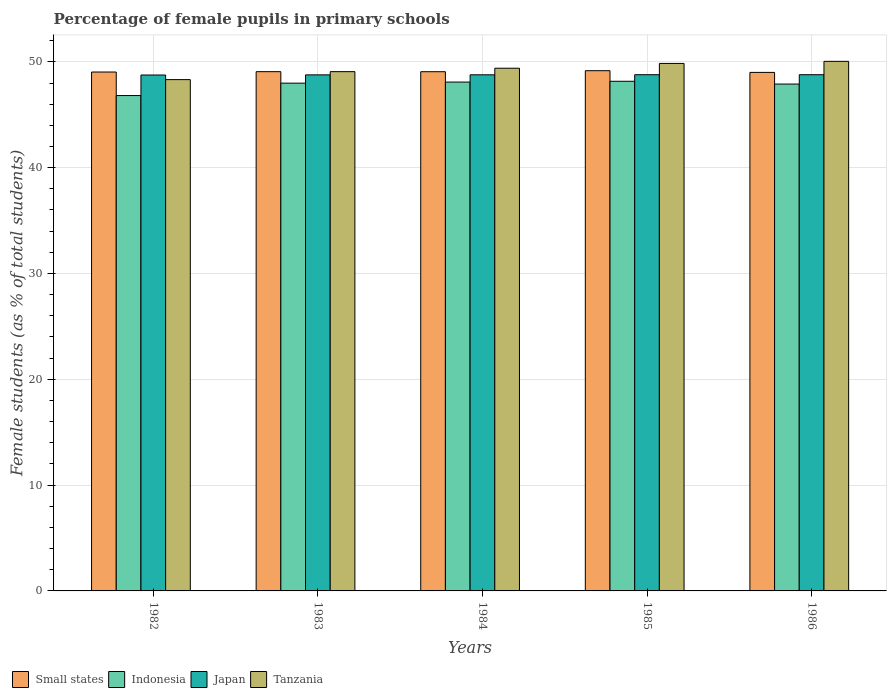How many different coloured bars are there?
Offer a very short reply. 4. How many groups of bars are there?
Offer a very short reply. 5. Are the number of bars per tick equal to the number of legend labels?
Your response must be concise. Yes. What is the percentage of female pupils in primary schools in Indonesia in 1985?
Your response must be concise. 48.16. Across all years, what is the maximum percentage of female pupils in primary schools in Small states?
Give a very brief answer. 49.16. Across all years, what is the minimum percentage of female pupils in primary schools in Japan?
Keep it short and to the point. 48.76. In which year was the percentage of female pupils in primary schools in Tanzania maximum?
Keep it short and to the point. 1986. In which year was the percentage of female pupils in primary schools in Small states minimum?
Give a very brief answer. 1986. What is the total percentage of female pupils in primary schools in Tanzania in the graph?
Keep it short and to the point. 246.69. What is the difference between the percentage of female pupils in primary schools in Small states in 1985 and that in 1986?
Give a very brief answer. 0.16. What is the difference between the percentage of female pupils in primary schools in Japan in 1983 and the percentage of female pupils in primary schools in Tanzania in 1985?
Offer a terse response. -1.08. What is the average percentage of female pupils in primary schools in Japan per year?
Give a very brief answer. 48.77. In the year 1983, what is the difference between the percentage of female pupils in primary schools in Indonesia and percentage of female pupils in primary schools in Small states?
Offer a terse response. -1.09. In how many years, is the percentage of female pupils in primary schools in Japan greater than 38 %?
Your answer should be very brief. 5. What is the ratio of the percentage of female pupils in primary schools in Tanzania in 1985 to that in 1986?
Offer a very short reply. 1. What is the difference between the highest and the second highest percentage of female pupils in primary schools in Tanzania?
Provide a short and direct response. 0.2. What is the difference between the highest and the lowest percentage of female pupils in primary schools in Small states?
Your answer should be compact. 0.16. What does the 4th bar from the left in 1984 represents?
Provide a short and direct response. Tanzania. What does the 4th bar from the right in 1984 represents?
Offer a terse response. Small states. Are all the bars in the graph horizontal?
Provide a succinct answer. No. Are the values on the major ticks of Y-axis written in scientific E-notation?
Your response must be concise. No. Does the graph contain grids?
Your response must be concise. Yes. What is the title of the graph?
Give a very brief answer. Percentage of female pupils in primary schools. Does "Belgium" appear as one of the legend labels in the graph?
Your answer should be very brief. No. What is the label or title of the X-axis?
Provide a succinct answer. Years. What is the label or title of the Y-axis?
Your answer should be compact. Female students (as % of total students). What is the Female students (as % of total students) of Small states in 1982?
Keep it short and to the point. 49.04. What is the Female students (as % of total students) of Indonesia in 1982?
Offer a terse response. 46.81. What is the Female students (as % of total students) in Japan in 1982?
Give a very brief answer. 48.76. What is the Female students (as % of total students) of Tanzania in 1982?
Offer a terse response. 48.32. What is the Female students (as % of total students) in Small states in 1983?
Provide a short and direct response. 49.07. What is the Female students (as % of total students) of Indonesia in 1983?
Keep it short and to the point. 47.99. What is the Female students (as % of total students) in Japan in 1983?
Your response must be concise. 48.77. What is the Female students (as % of total students) of Tanzania in 1983?
Your answer should be compact. 49.07. What is the Female students (as % of total students) of Small states in 1984?
Keep it short and to the point. 49.07. What is the Female students (as % of total students) of Indonesia in 1984?
Provide a succinct answer. 48.09. What is the Female students (as % of total students) of Japan in 1984?
Your answer should be very brief. 48.77. What is the Female students (as % of total students) of Tanzania in 1984?
Make the answer very short. 49.4. What is the Female students (as % of total students) of Small states in 1985?
Provide a short and direct response. 49.16. What is the Female students (as % of total students) of Indonesia in 1985?
Give a very brief answer. 48.16. What is the Female students (as % of total students) in Japan in 1985?
Your answer should be compact. 48.78. What is the Female students (as % of total students) of Tanzania in 1985?
Make the answer very short. 49.85. What is the Female students (as % of total students) in Small states in 1986?
Your response must be concise. 49. What is the Female students (as % of total students) in Indonesia in 1986?
Your answer should be very brief. 47.9. What is the Female students (as % of total students) of Japan in 1986?
Give a very brief answer. 48.79. What is the Female students (as % of total students) in Tanzania in 1986?
Ensure brevity in your answer.  50.05. Across all years, what is the maximum Female students (as % of total students) in Small states?
Offer a terse response. 49.16. Across all years, what is the maximum Female students (as % of total students) of Indonesia?
Offer a terse response. 48.16. Across all years, what is the maximum Female students (as % of total students) of Japan?
Provide a short and direct response. 48.79. Across all years, what is the maximum Female students (as % of total students) in Tanzania?
Provide a succinct answer. 50.05. Across all years, what is the minimum Female students (as % of total students) in Small states?
Provide a short and direct response. 49. Across all years, what is the minimum Female students (as % of total students) of Indonesia?
Your answer should be compact. 46.81. Across all years, what is the minimum Female students (as % of total students) in Japan?
Provide a succinct answer. 48.76. Across all years, what is the minimum Female students (as % of total students) of Tanzania?
Provide a succinct answer. 48.32. What is the total Female students (as % of total students) of Small states in the graph?
Provide a short and direct response. 245.35. What is the total Female students (as % of total students) of Indonesia in the graph?
Your answer should be very brief. 238.95. What is the total Female students (as % of total students) of Japan in the graph?
Provide a short and direct response. 243.87. What is the total Female students (as % of total students) of Tanzania in the graph?
Make the answer very short. 246.69. What is the difference between the Female students (as % of total students) in Small states in 1982 and that in 1983?
Ensure brevity in your answer.  -0.03. What is the difference between the Female students (as % of total students) in Indonesia in 1982 and that in 1983?
Keep it short and to the point. -1.17. What is the difference between the Female students (as % of total students) in Japan in 1982 and that in 1983?
Offer a terse response. -0.01. What is the difference between the Female students (as % of total students) of Tanzania in 1982 and that in 1983?
Provide a succinct answer. -0.75. What is the difference between the Female students (as % of total students) of Small states in 1982 and that in 1984?
Offer a very short reply. -0.03. What is the difference between the Female students (as % of total students) in Indonesia in 1982 and that in 1984?
Your response must be concise. -1.27. What is the difference between the Female students (as % of total students) in Japan in 1982 and that in 1984?
Provide a short and direct response. -0.02. What is the difference between the Female students (as % of total students) of Tanzania in 1982 and that in 1984?
Provide a succinct answer. -1.08. What is the difference between the Female students (as % of total students) in Small states in 1982 and that in 1985?
Keep it short and to the point. -0.12. What is the difference between the Female students (as % of total students) in Indonesia in 1982 and that in 1985?
Offer a very short reply. -1.35. What is the difference between the Female students (as % of total students) of Japan in 1982 and that in 1985?
Give a very brief answer. -0.03. What is the difference between the Female students (as % of total students) of Tanzania in 1982 and that in 1985?
Give a very brief answer. -1.53. What is the difference between the Female students (as % of total students) of Small states in 1982 and that in 1986?
Provide a succinct answer. 0.04. What is the difference between the Female students (as % of total students) of Indonesia in 1982 and that in 1986?
Offer a terse response. -1.09. What is the difference between the Female students (as % of total students) of Japan in 1982 and that in 1986?
Offer a very short reply. -0.03. What is the difference between the Female students (as % of total students) of Tanzania in 1982 and that in 1986?
Ensure brevity in your answer.  -1.73. What is the difference between the Female students (as % of total students) of Small states in 1983 and that in 1984?
Your answer should be very brief. 0. What is the difference between the Female students (as % of total students) of Indonesia in 1983 and that in 1984?
Offer a very short reply. -0.1. What is the difference between the Female students (as % of total students) in Japan in 1983 and that in 1984?
Offer a very short reply. -0.01. What is the difference between the Female students (as % of total students) of Tanzania in 1983 and that in 1984?
Give a very brief answer. -0.32. What is the difference between the Female students (as % of total students) in Small states in 1983 and that in 1985?
Keep it short and to the point. -0.09. What is the difference between the Female students (as % of total students) of Indonesia in 1983 and that in 1985?
Keep it short and to the point. -0.18. What is the difference between the Female students (as % of total students) of Japan in 1983 and that in 1985?
Your answer should be very brief. -0.01. What is the difference between the Female students (as % of total students) in Tanzania in 1983 and that in 1985?
Offer a terse response. -0.78. What is the difference between the Female students (as % of total students) of Small states in 1983 and that in 1986?
Your answer should be compact. 0.07. What is the difference between the Female students (as % of total students) in Indonesia in 1983 and that in 1986?
Provide a short and direct response. 0.09. What is the difference between the Female students (as % of total students) of Japan in 1983 and that in 1986?
Make the answer very short. -0.02. What is the difference between the Female students (as % of total students) of Tanzania in 1983 and that in 1986?
Your answer should be compact. -0.97. What is the difference between the Female students (as % of total students) of Small states in 1984 and that in 1985?
Make the answer very short. -0.1. What is the difference between the Female students (as % of total students) in Indonesia in 1984 and that in 1985?
Ensure brevity in your answer.  -0.08. What is the difference between the Female students (as % of total students) of Japan in 1984 and that in 1985?
Provide a short and direct response. -0.01. What is the difference between the Female students (as % of total students) in Tanzania in 1984 and that in 1985?
Your answer should be compact. -0.45. What is the difference between the Female students (as % of total students) of Small states in 1984 and that in 1986?
Offer a terse response. 0.06. What is the difference between the Female students (as % of total students) in Indonesia in 1984 and that in 1986?
Provide a short and direct response. 0.19. What is the difference between the Female students (as % of total students) in Japan in 1984 and that in 1986?
Provide a succinct answer. -0.01. What is the difference between the Female students (as % of total students) in Tanzania in 1984 and that in 1986?
Provide a succinct answer. -0.65. What is the difference between the Female students (as % of total students) in Small states in 1985 and that in 1986?
Your response must be concise. 0.16. What is the difference between the Female students (as % of total students) of Indonesia in 1985 and that in 1986?
Offer a very short reply. 0.26. What is the difference between the Female students (as % of total students) of Japan in 1985 and that in 1986?
Give a very brief answer. -0. What is the difference between the Female students (as % of total students) in Tanzania in 1985 and that in 1986?
Give a very brief answer. -0.2. What is the difference between the Female students (as % of total students) of Small states in 1982 and the Female students (as % of total students) of Indonesia in 1983?
Your response must be concise. 1.05. What is the difference between the Female students (as % of total students) in Small states in 1982 and the Female students (as % of total students) in Japan in 1983?
Provide a short and direct response. 0.27. What is the difference between the Female students (as % of total students) in Small states in 1982 and the Female students (as % of total students) in Tanzania in 1983?
Give a very brief answer. -0.04. What is the difference between the Female students (as % of total students) in Indonesia in 1982 and the Female students (as % of total students) in Japan in 1983?
Your response must be concise. -1.96. What is the difference between the Female students (as % of total students) in Indonesia in 1982 and the Female students (as % of total students) in Tanzania in 1983?
Provide a short and direct response. -2.26. What is the difference between the Female students (as % of total students) of Japan in 1982 and the Female students (as % of total students) of Tanzania in 1983?
Ensure brevity in your answer.  -0.32. What is the difference between the Female students (as % of total students) of Small states in 1982 and the Female students (as % of total students) of Indonesia in 1984?
Your answer should be compact. 0.95. What is the difference between the Female students (as % of total students) of Small states in 1982 and the Female students (as % of total students) of Japan in 1984?
Offer a very short reply. 0.26. What is the difference between the Female students (as % of total students) in Small states in 1982 and the Female students (as % of total students) in Tanzania in 1984?
Provide a succinct answer. -0.36. What is the difference between the Female students (as % of total students) in Indonesia in 1982 and the Female students (as % of total students) in Japan in 1984?
Your answer should be compact. -1.96. What is the difference between the Female students (as % of total students) of Indonesia in 1982 and the Female students (as % of total students) of Tanzania in 1984?
Provide a short and direct response. -2.58. What is the difference between the Female students (as % of total students) of Japan in 1982 and the Female students (as % of total students) of Tanzania in 1984?
Offer a terse response. -0.64. What is the difference between the Female students (as % of total students) of Small states in 1982 and the Female students (as % of total students) of Indonesia in 1985?
Your response must be concise. 0.87. What is the difference between the Female students (as % of total students) of Small states in 1982 and the Female students (as % of total students) of Japan in 1985?
Keep it short and to the point. 0.25. What is the difference between the Female students (as % of total students) of Small states in 1982 and the Female students (as % of total students) of Tanzania in 1985?
Make the answer very short. -0.81. What is the difference between the Female students (as % of total students) in Indonesia in 1982 and the Female students (as % of total students) in Japan in 1985?
Provide a succinct answer. -1.97. What is the difference between the Female students (as % of total students) in Indonesia in 1982 and the Female students (as % of total students) in Tanzania in 1985?
Give a very brief answer. -3.04. What is the difference between the Female students (as % of total students) in Japan in 1982 and the Female students (as % of total students) in Tanzania in 1985?
Ensure brevity in your answer.  -1.09. What is the difference between the Female students (as % of total students) of Small states in 1982 and the Female students (as % of total students) of Indonesia in 1986?
Your answer should be compact. 1.14. What is the difference between the Female students (as % of total students) in Small states in 1982 and the Female students (as % of total students) in Japan in 1986?
Your answer should be compact. 0.25. What is the difference between the Female students (as % of total students) in Small states in 1982 and the Female students (as % of total students) in Tanzania in 1986?
Offer a terse response. -1.01. What is the difference between the Female students (as % of total students) of Indonesia in 1982 and the Female students (as % of total students) of Japan in 1986?
Provide a succinct answer. -1.97. What is the difference between the Female students (as % of total students) in Indonesia in 1982 and the Female students (as % of total students) in Tanzania in 1986?
Keep it short and to the point. -3.23. What is the difference between the Female students (as % of total students) in Japan in 1982 and the Female students (as % of total students) in Tanzania in 1986?
Your response must be concise. -1.29. What is the difference between the Female students (as % of total students) in Small states in 1983 and the Female students (as % of total students) in Indonesia in 1984?
Provide a succinct answer. 0.98. What is the difference between the Female students (as % of total students) of Small states in 1983 and the Female students (as % of total students) of Japan in 1984?
Provide a succinct answer. 0.3. What is the difference between the Female students (as % of total students) of Small states in 1983 and the Female students (as % of total students) of Tanzania in 1984?
Make the answer very short. -0.32. What is the difference between the Female students (as % of total students) of Indonesia in 1983 and the Female students (as % of total students) of Japan in 1984?
Keep it short and to the point. -0.79. What is the difference between the Female students (as % of total students) of Indonesia in 1983 and the Female students (as % of total students) of Tanzania in 1984?
Provide a succinct answer. -1.41. What is the difference between the Female students (as % of total students) in Japan in 1983 and the Female students (as % of total students) in Tanzania in 1984?
Ensure brevity in your answer.  -0.63. What is the difference between the Female students (as % of total students) of Small states in 1983 and the Female students (as % of total students) of Indonesia in 1985?
Your response must be concise. 0.91. What is the difference between the Female students (as % of total students) in Small states in 1983 and the Female students (as % of total students) in Japan in 1985?
Your response must be concise. 0.29. What is the difference between the Female students (as % of total students) of Small states in 1983 and the Female students (as % of total students) of Tanzania in 1985?
Keep it short and to the point. -0.78. What is the difference between the Female students (as % of total students) of Indonesia in 1983 and the Female students (as % of total students) of Japan in 1985?
Keep it short and to the point. -0.8. What is the difference between the Female students (as % of total students) of Indonesia in 1983 and the Female students (as % of total students) of Tanzania in 1985?
Ensure brevity in your answer.  -1.86. What is the difference between the Female students (as % of total students) in Japan in 1983 and the Female students (as % of total students) in Tanzania in 1985?
Make the answer very short. -1.08. What is the difference between the Female students (as % of total students) in Small states in 1983 and the Female students (as % of total students) in Indonesia in 1986?
Provide a succinct answer. 1.17. What is the difference between the Female students (as % of total students) of Small states in 1983 and the Female students (as % of total students) of Japan in 1986?
Provide a succinct answer. 0.29. What is the difference between the Female students (as % of total students) of Small states in 1983 and the Female students (as % of total students) of Tanzania in 1986?
Offer a terse response. -0.97. What is the difference between the Female students (as % of total students) of Indonesia in 1983 and the Female students (as % of total students) of Japan in 1986?
Your answer should be compact. -0.8. What is the difference between the Female students (as % of total students) of Indonesia in 1983 and the Female students (as % of total students) of Tanzania in 1986?
Your response must be concise. -2.06. What is the difference between the Female students (as % of total students) of Japan in 1983 and the Female students (as % of total students) of Tanzania in 1986?
Ensure brevity in your answer.  -1.28. What is the difference between the Female students (as % of total students) of Small states in 1984 and the Female students (as % of total students) of Indonesia in 1985?
Offer a terse response. 0.9. What is the difference between the Female students (as % of total students) in Small states in 1984 and the Female students (as % of total students) in Japan in 1985?
Provide a succinct answer. 0.28. What is the difference between the Female students (as % of total students) of Small states in 1984 and the Female students (as % of total students) of Tanzania in 1985?
Give a very brief answer. -0.78. What is the difference between the Female students (as % of total students) in Indonesia in 1984 and the Female students (as % of total students) in Japan in 1985?
Provide a short and direct response. -0.7. What is the difference between the Female students (as % of total students) of Indonesia in 1984 and the Female students (as % of total students) of Tanzania in 1985?
Ensure brevity in your answer.  -1.76. What is the difference between the Female students (as % of total students) in Japan in 1984 and the Female students (as % of total students) in Tanzania in 1985?
Make the answer very short. -1.08. What is the difference between the Female students (as % of total students) in Small states in 1984 and the Female students (as % of total students) in Indonesia in 1986?
Your answer should be compact. 1.17. What is the difference between the Female students (as % of total students) of Small states in 1984 and the Female students (as % of total students) of Japan in 1986?
Offer a very short reply. 0.28. What is the difference between the Female students (as % of total students) of Small states in 1984 and the Female students (as % of total students) of Tanzania in 1986?
Make the answer very short. -0.98. What is the difference between the Female students (as % of total students) of Indonesia in 1984 and the Female students (as % of total students) of Japan in 1986?
Provide a succinct answer. -0.7. What is the difference between the Female students (as % of total students) in Indonesia in 1984 and the Female students (as % of total students) in Tanzania in 1986?
Provide a short and direct response. -1.96. What is the difference between the Female students (as % of total students) of Japan in 1984 and the Female students (as % of total students) of Tanzania in 1986?
Keep it short and to the point. -1.27. What is the difference between the Female students (as % of total students) in Small states in 1985 and the Female students (as % of total students) in Indonesia in 1986?
Ensure brevity in your answer.  1.26. What is the difference between the Female students (as % of total students) in Small states in 1985 and the Female students (as % of total students) in Japan in 1986?
Keep it short and to the point. 0.38. What is the difference between the Female students (as % of total students) of Small states in 1985 and the Female students (as % of total students) of Tanzania in 1986?
Provide a succinct answer. -0.88. What is the difference between the Female students (as % of total students) of Indonesia in 1985 and the Female students (as % of total students) of Japan in 1986?
Your response must be concise. -0.62. What is the difference between the Female students (as % of total students) in Indonesia in 1985 and the Female students (as % of total students) in Tanzania in 1986?
Give a very brief answer. -1.88. What is the difference between the Female students (as % of total students) of Japan in 1985 and the Female students (as % of total students) of Tanzania in 1986?
Your answer should be very brief. -1.26. What is the average Female students (as % of total students) in Small states per year?
Provide a short and direct response. 49.07. What is the average Female students (as % of total students) of Indonesia per year?
Provide a succinct answer. 47.79. What is the average Female students (as % of total students) of Japan per year?
Your response must be concise. 48.77. What is the average Female students (as % of total students) of Tanzania per year?
Your response must be concise. 49.34. In the year 1982, what is the difference between the Female students (as % of total students) in Small states and Female students (as % of total students) in Indonesia?
Give a very brief answer. 2.22. In the year 1982, what is the difference between the Female students (as % of total students) of Small states and Female students (as % of total students) of Japan?
Your answer should be compact. 0.28. In the year 1982, what is the difference between the Female students (as % of total students) of Small states and Female students (as % of total students) of Tanzania?
Give a very brief answer. 0.72. In the year 1982, what is the difference between the Female students (as % of total students) in Indonesia and Female students (as % of total students) in Japan?
Provide a succinct answer. -1.94. In the year 1982, what is the difference between the Female students (as % of total students) in Indonesia and Female students (as % of total students) in Tanzania?
Keep it short and to the point. -1.51. In the year 1982, what is the difference between the Female students (as % of total students) in Japan and Female students (as % of total students) in Tanzania?
Keep it short and to the point. 0.44. In the year 1983, what is the difference between the Female students (as % of total students) of Small states and Female students (as % of total students) of Indonesia?
Give a very brief answer. 1.09. In the year 1983, what is the difference between the Female students (as % of total students) of Small states and Female students (as % of total students) of Japan?
Make the answer very short. 0.3. In the year 1983, what is the difference between the Female students (as % of total students) of Small states and Female students (as % of total students) of Tanzania?
Ensure brevity in your answer.  -0. In the year 1983, what is the difference between the Female students (as % of total students) of Indonesia and Female students (as % of total students) of Japan?
Offer a very short reply. -0.78. In the year 1983, what is the difference between the Female students (as % of total students) in Indonesia and Female students (as % of total students) in Tanzania?
Keep it short and to the point. -1.09. In the year 1983, what is the difference between the Female students (as % of total students) of Japan and Female students (as % of total students) of Tanzania?
Give a very brief answer. -0.3. In the year 1984, what is the difference between the Female students (as % of total students) in Small states and Female students (as % of total students) in Indonesia?
Offer a very short reply. 0.98. In the year 1984, what is the difference between the Female students (as % of total students) in Small states and Female students (as % of total students) in Japan?
Your response must be concise. 0.29. In the year 1984, what is the difference between the Female students (as % of total students) in Small states and Female students (as % of total students) in Tanzania?
Offer a very short reply. -0.33. In the year 1984, what is the difference between the Female students (as % of total students) in Indonesia and Female students (as % of total students) in Japan?
Your answer should be very brief. -0.69. In the year 1984, what is the difference between the Female students (as % of total students) in Indonesia and Female students (as % of total students) in Tanzania?
Your answer should be very brief. -1.31. In the year 1984, what is the difference between the Female students (as % of total students) of Japan and Female students (as % of total students) of Tanzania?
Your answer should be compact. -0.62. In the year 1985, what is the difference between the Female students (as % of total students) in Small states and Female students (as % of total students) in Indonesia?
Keep it short and to the point. 1. In the year 1985, what is the difference between the Female students (as % of total students) of Small states and Female students (as % of total students) of Japan?
Your response must be concise. 0.38. In the year 1985, what is the difference between the Female students (as % of total students) of Small states and Female students (as % of total students) of Tanzania?
Provide a succinct answer. -0.69. In the year 1985, what is the difference between the Female students (as % of total students) of Indonesia and Female students (as % of total students) of Japan?
Ensure brevity in your answer.  -0.62. In the year 1985, what is the difference between the Female students (as % of total students) of Indonesia and Female students (as % of total students) of Tanzania?
Your response must be concise. -1.69. In the year 1985, what is the difference between the Female students (as % of total students) in Japan and Female students (as % of total students) in Tanzania?
Your response must be concise. -1.07. In the year 1986, what is the difference between the Female students (as % of total students) of Small states and Female students (as % of total students) of Indonesia?
Your answer should be very brief. 1.1. In the year 1986, what is the difference between the Female students (as % of total students) of Small states and Female students (as % of total students) of Japan?
Offer a very short reply. 0.22. In the year 1986, what is the difference between the Female students (as % of total students) of Small states and Female students (as % of total students) of Tanzania?
Offer a very short reply. -1.04. In the year 1986, what is the difference between the Female students (as % of total students) in Indonesia and Female students (as % of total students) in Japan?
Give a very brief answer. -0.88. In the year 1986, what is the difference between the Female students (as % of total students) of Indonesia and Female students (as % of total students) of Tanzania?
Provide a succinct answer. -2.15. In the year 1986, what is the difference between the Female students (as % of total students) of Japan and Female students (as % of total students) of Tanzania?
Give a very brief answer. -1.26. What is the ratio of the Female students (as % of total students) in Indonesia in 1982 to that in 1983?
Your response must be concise. 0.98. What is the ratio of the Female students (as % of total students) in Japan in 1982 to that in 1983?
Provide a succinct answer. 1. What is the ratio of the Female students (as % of total students) in Tanzania in 1982 to that in 1983?
Provide a succinct answer. 0.98. What is the ratio of the Female students (as % of total students) in Small states in 1982 to that in 1984?
Ensure brevity in your answer.  1. What is the ratio of the Female students (as % of total students) in Indonesia in 1982 to that in 1984?
Provide a short and direct response. 0.97. What is the ratio of the Female students (as % of total students) of Tanzania in 1982 to that in 1984?
Offer a terse response. 0.98. What is the ratio of the Female students (as % of total students) in Small states in 1982 to that in 1985?
Offer a very short reply. 1. What is the ratio of the Female students (as % of total students) in Indonesia in 1982 to that in 1985?
Your response must be concise. 0.97. What is the ratio of the Female students (as % of total students) of Japan in 1982 to that in 1985?
Offer a terse response. 1. What is the ratio of the Female students (as % of total students) in Tanzania in 1982 to that in 1985?
Make the answer very short. 0.97. What is the ratio of the Female students (as % of total students) of Small states in 1982 to that in 1986?
Give a very brief answer. 1. What is the ratio of the Female students (as % of total students) in Indonesia in 1982 to that in 1986?
Offer a very short reply. 0.98. What is the ratio of the Female students (as % of total students) of Tanzania in 1982 to that in 1986?
Offer a very short reply. 0.97. What is the ratio of the Female students (as % of total students) of Indonesia in 1983 to that in 1984?
Offer a very short reply. 1. What is the ratio of the Female students (as % of total students) in Japan in 1983 to that in 1984?
Provide a succinct answer. 1. What is the ratio of the Female students (as % of total students) in Small states in 1983 to that in 1985?
Ensure brevity in your answer.  1. What is the ratio of the Female students (as % of total students) of Indonesia in 1983 to that in 1985?
Provide a short and direct response. 1. What is the ratio of the Female students (as % of total students) in Japan in 1983 to that in 1985?
Provide a short and direct response. 1. What is the ratio of the Female students (as % of total students) of Tanzania in 1983 to that in 1985?
Your answer should be very brief. 0.98. What is the ratio of the Female students (as % of total students) of Indonesia in 1983 to that in 1986?
Keep it short and to the point. 1. What is the ratio of the Female students (as % of total students) of Tanzania in 1983 to that in 1986?
Your response must be concise. 0.98. What is the ratio of the Female students (as % of total students) of Small states in 1984 to that in 1985?
Give a very brief answer. 1. What is the ratio of the Female students (as % of total students) of Tanzania in 1984 to that in 1985?
Offer a terse response. 0.99. What is the ratio of the Female students (as % of total students) of Tanzania in 1984 to that in 1986?
Your answer should be very brief. 0.99. What is the difference between the highest and the second highest Female students (as % of total students) in Small states?
Offer a terse response. 0.09. What is the difference between the highest and the second highest Female students (as % of total students) in Indonesia?
Provide a succinct answer. 0.08. What is the difference between the highest and the second highest Female students (as % of total students) in Japan?
Give a very brief answer. 0. What is the difference between the highest and the second highest Female students (as % of total students) of Tanzania?
Provide a short and direct response. 0.2. What is the difference between the highest and the lowest Female students (as % of total students) of Small states?
Your response must be concise. 0.16. What is the difference between the highest and the lowest Female students (as % of total students) in Indonesia?
Give a very brief answer. 1.35. What is the difference between the highest and the lowest Female students (as % of total students) in Japan?
Your answer should be compact. 0.03. What is the difference between the highest and the lowest Female students (as % of total students) in Tanzania?
Your answer should be compact. 1.73. 